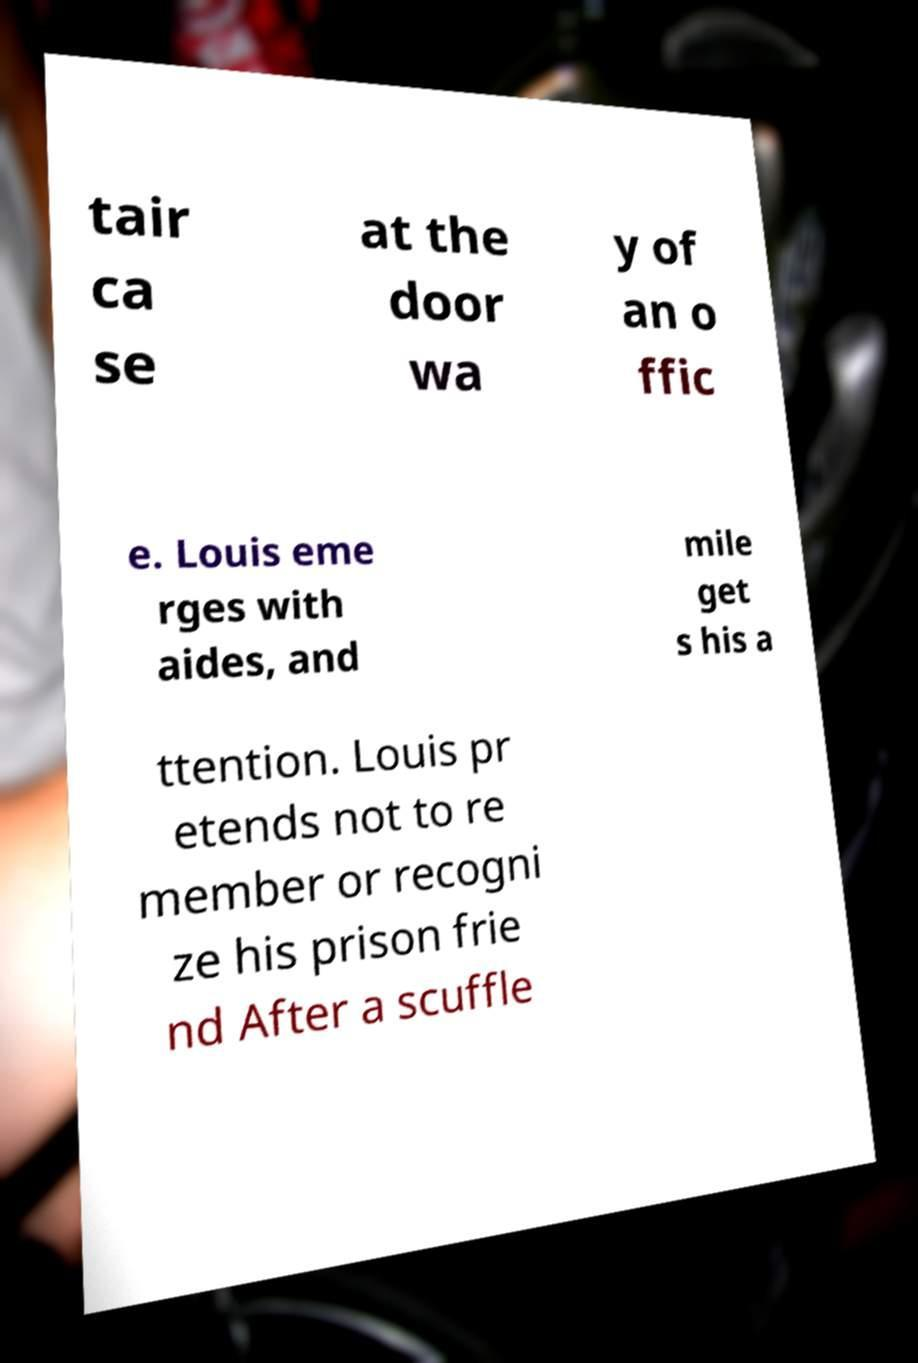Could you extract and type out the text from this image? tair ca se at the door wa y of an o ffic e. Louis eme rges with aides, and mile get s his a ttention. Louis pr etends not to re member or recogni ze his prison frie nd After a scuffle 